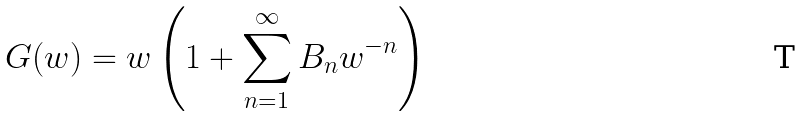Convert formula to latex. <formula><loc_0><loc_0><loc_500><loc_500>G ( w ) = w \left ( 1 + \sum _ { n = 1 } ^ { \infty } B _ { n } w ^ { - n } \right )</formula> 